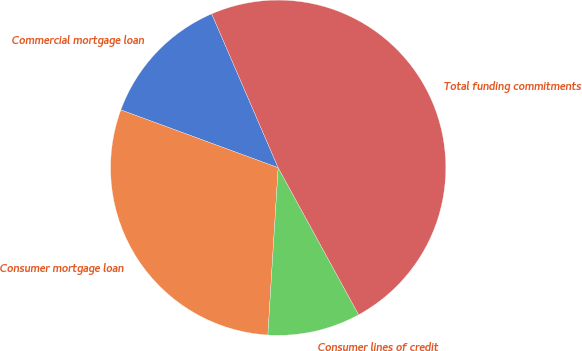Convert chart. <chart><loc_0><loc_0><loc_500><loc_500><pie_chart><fcel>Commercial mortgage loan<fcel>Consumer mortgage loan<fcel>Consumer lines of credit<fcel>Total funding commitments<nl><fcel>12.91%<fcel>29.62%<fcel>8.95%<fcel>48.51%<nl></chart> 